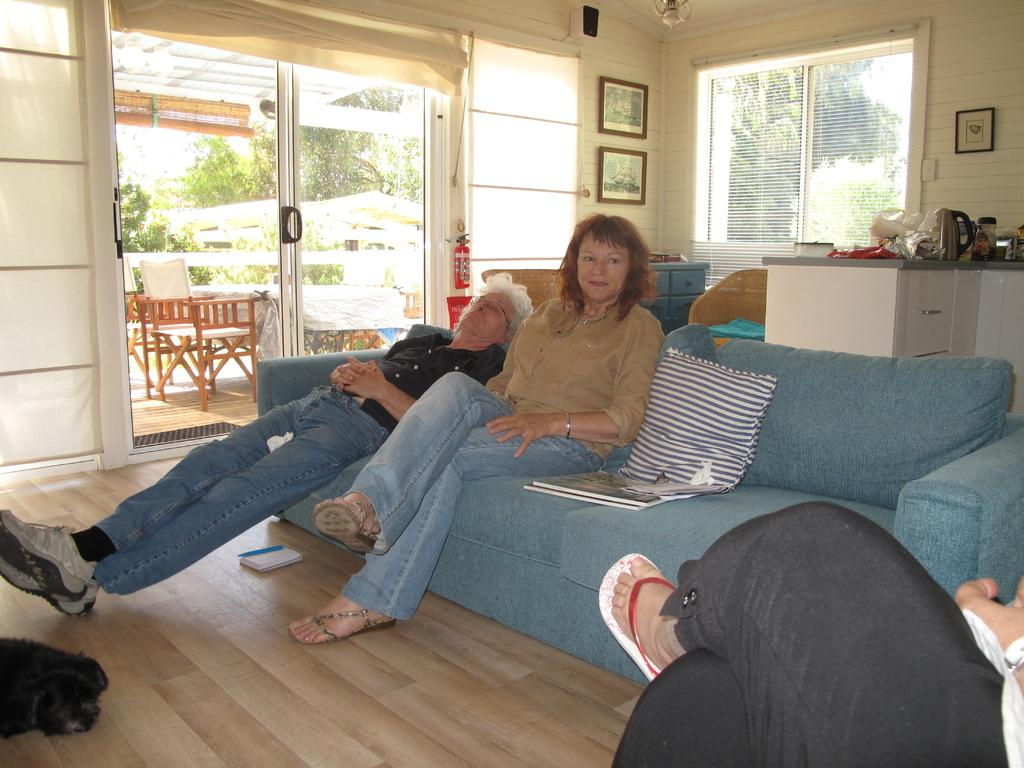How many people are sitting on the sofa in the image? There are two women sitting on a sofa in the image. What part of a person's body is visible in the image? There is a leg of a person visible in the image. What type of furniture is present in the image besides the sofa? There are chairs in the image. What type of natural scenery can be seen in the image? There are trees in the image. What type of payment method is being used by the mother in the image? There is no mother or payment method present in the image. How does the sand appear in the image? There is no sand present in the image. 